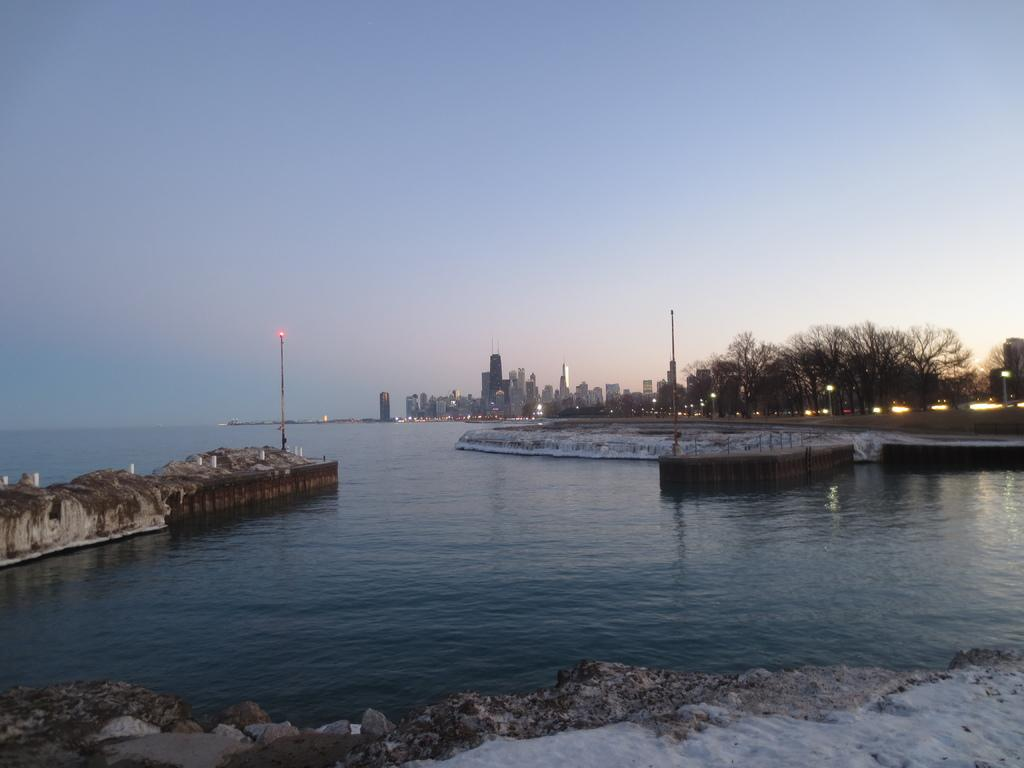What type of natural body of water is visible in the image? There is a sea in the image. What type of surface surrounds the sea? There is a sand surface around the sea. What can be seen in the distance in the image? There are buildings and trees in the background of the image. What type of whistle can be heard coming from the sea in the image? There is no whistle present in the image, as it is a still image and does not contain any sounds. 